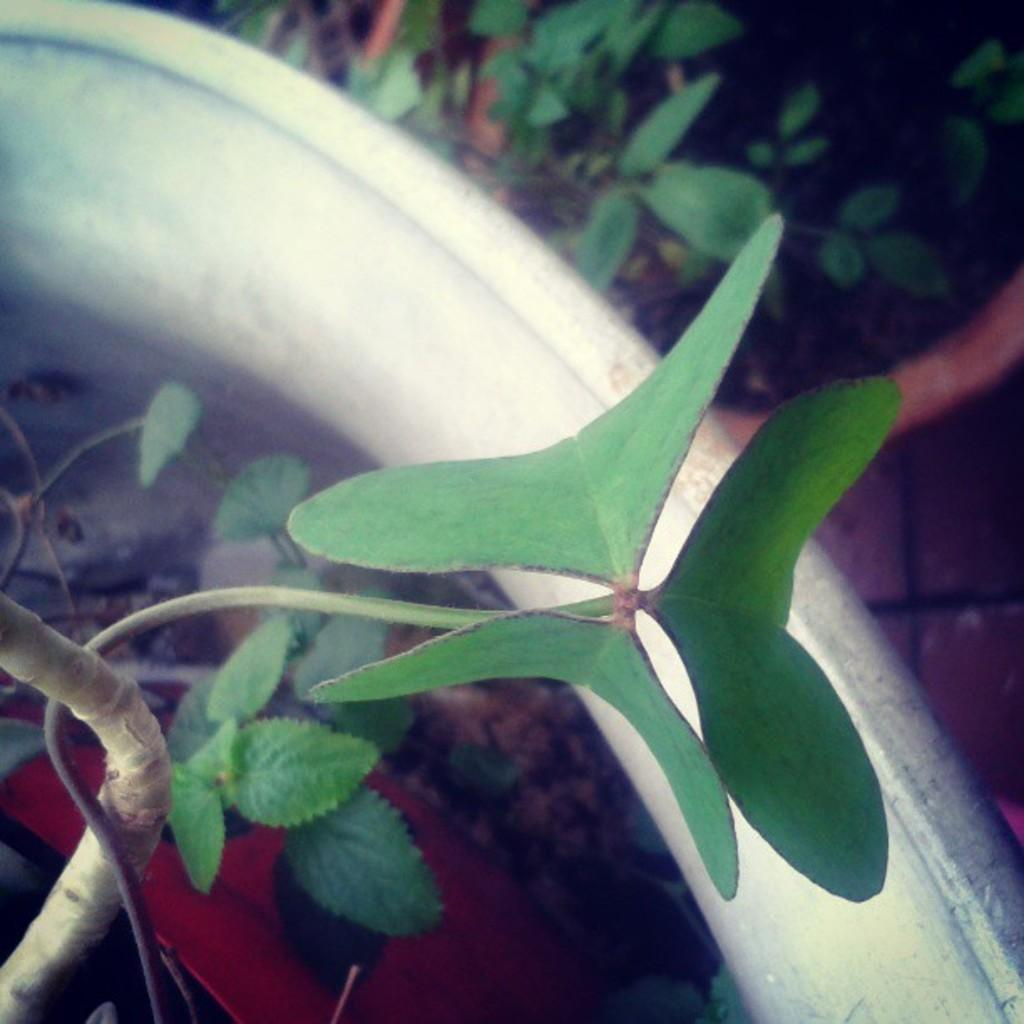What type of living organisms can be seen in the image? Plants can be seen in the image. What else is present in the image that resembles a plant-based item? There is an object that looks like a vegetable in the image. Can you describe the red color object in the image? Yes, there is a red color object towards the bottom of the image. What type of dust can be seen on the territory in the image? There is no dust or territory present in the image; it features plants and an object that looks like a vegetable. How many sons are visible in the image? There are no people, let alone sons, present in the image. 